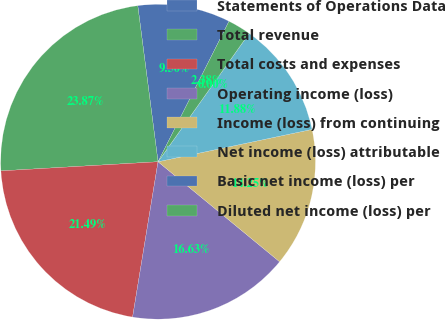Convert chart. <chart><loc_0><loc_0><loc_500><loc_500><pie_chart><fcel>Statements of Operations Data<fcel>Total revenue<fcel>Total costs and expenses<fcel>Operating income (loss)<fcel>Income (loss) from continuing<fcel>Net income (loss) attributable<fcel>Basic net income (loss) per<fcel>Diluted net income (loss) per<nl><fcel>9.5%<fcel>23.87%<fcel>21.49%<fcel>16.63%<fcel>14.25%<fcel>11.88%<fcel>0.0%<fcel>2.38%<nl></chart> 